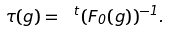Convert formula to latex. <formula><loc_0><loc_0><loc_500><loc_500>\tau ( g ) = \ ^ { t } ( F _ { 0 } ( g ) ) ^ { - 1 } .</formula> 